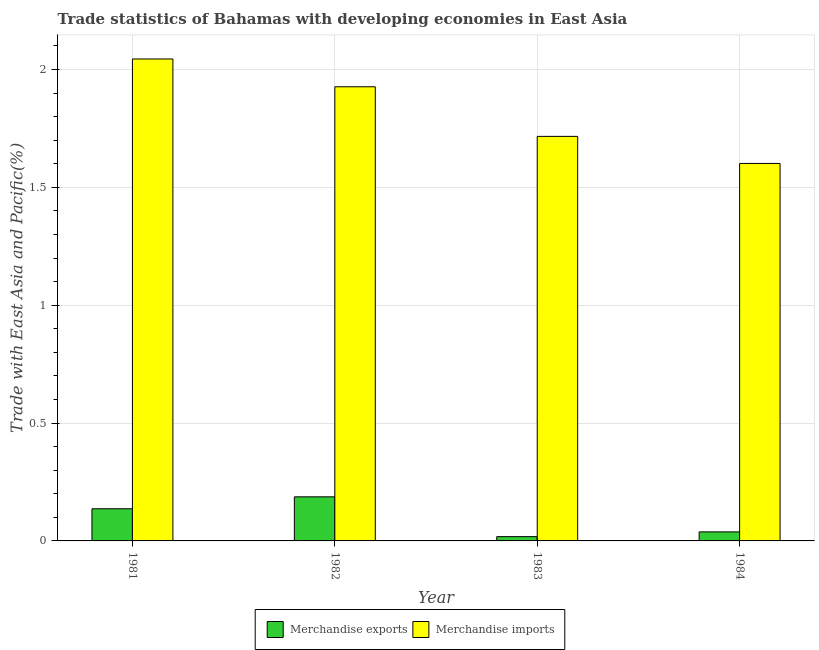How many different coloured bars are there?
Give a very brief answer. 2. How many groups of bars are there?
Offer a very short reply. 4. Are the number of bars on each tick of the X-axis equal?
Provide a succinct answer. Yes. How many bars are there on the 3rd tick from the right?
Ensure brevity in your answer.  2. What is the merchandise imports in 1983?
Offer a terse response. 1.72. Across all years, what is the maximum merchandise exports?
Make the answer very short. 0.19. Across all years, what is the minimum merchandise exports?
Make the answer very short. 0.02. In which year was the merchandise exports minimum?
Give a very brief answer. 1983. What is the total merchandise imports in the graph?
Your response must be concise. 7.29. What is the difference between the merchandise imports in 1981 and that in 1984?
Offer a very short reply. 0.44. What is the difference between the merchandise exports in 1981 and the merchandise imports in 1982?
Your answer should be compact. -0.05. What is the average merchandise exports per year?
Keep it short and to the point. 0.09. In the year 1981, what is the difference between the merchandise exports and merchandise imports?
Your response must be concise. 0. What is the ratio of the merchandise imports in 1981 to that in 1983?
Make the answer very short. 1.19. What is the difference between the highest and the second highest merchandise exports?
Your answer should be compact. 0.05. What is the difference between the highest and the lowest merchandise imports?
Make the answer very short. 0.44. What does the 2nd bar from the left in 1983 represents?
Make the answer very short. Merchandise imports. What does the 1st bar from the right in 1983 represents?
Your answer should be very brief. Merchandise imports. Are all the bars in the graph horizontal?
Offer a terse response. No. What is the difference between two consecutive major ticks on the Y-axis?
Provide a succinct answer. 0.5. Are the values on the major ticks of Y-axis written in scientific E-notation?
Keep it short and to the point. No. Does the graph contain any zero values?
Your answer should be very brief. No. Where does the legend appear in the graph?
Offer a very short reply. Bottom center. How many legend labels are there?
Give a very brief answer. 2. How are the legend labels stacked?
Ensure brevity in your answer.  Horizontal. What is the title of the graph?
Your response must be concise. Trade statistics of Bahamas with developing economies in East Asia. Does "IMF nonconcessional" appear as one of the legend labels in the graph?
Your answer should be compact. No. What is the label or title of the Y-axis?
Your answer should be very brief. Trade with East Asia and Pacific(%). What is the Trade with East Asia and Pacific(%) in Merchandise exports in 1981?
Your answer should be compact. 0.14. What is the Trade with East Asia and Pacific(%) in Merchandise imports in 1981?
Your answer should be compact. 2.04. What is the Trade with East Asia and Pacific(%) in Merchandise exports in 1982?
Your response must be concise. 0.19. What is the Trade with East Asia and Pacific(%) of Merchandise imports in 1982?
Provide a short and direct response. 1.93. What is the Trade with East Asia and Pacific(%) in Merchandise exports in 1983?
Provide a short and direct response. 0.02. What is the Trade with East Asia and Pacific(%) in Merchandise imports in 1983?
Ensure brevity in your answer.  1.72. What is the Trade with East Asia and Pacific(%) of Merchandise exports in 1984?
Keep it short and to the point. 0.04. What is the Trade with East Asia and Pacific(%) in Merchandise imports in 1984?
Your answer should be compact. 1.6. Across all years, what is the maximum Trade with East Asia and Pacific(%) in Merchandise exports?
Offer a terse response. 0.19. Across all years, what is the maximum Trade with East Asia and Pacific(%) of Merchandise imports?
Give a very brief answer. 2.04. Across all years, what is the minimum Trade with East Asia and Pacific(%) in Merchandise exports?
Your response must be concise. 0.02. Across all years, what is the minimum Trade with East Asia and Pacific(%) of Merchandise imports?
Your response must be concise. 1.6. What is the total Trade with East Asia and Pacific(%) in Merchandise exports in the graph?
Make the answer very short. 0.38. What is the total Trade with East Asia and Pacific(%) of Merchandise imports in the graph?
Your answer should be compact. 7.29. What is the difference between the Trade with East Asia and Pacific(%) in Merchandise exports in 1981 and that in 1982?
Offer a terse response. -0.05. What is the difference between the Trade with East Asia and Pacific(%) of Merchandise imports in 1981 and that in 1982?
Your answer should be compact. 0.12. What is the difference between the Trade with East Asia and Pacific(%) in Merchandise exports in 1981 and that in 1983?
Make the answer very short. 0.12. What is the difference between the Trade with East Asia and Pacific(%) in Merchandise imports in 1981 and that in 1983?
Offer a very short reply. 0.33. What is the difference between the Trade with East Asia and Pacific(%) of Merchandise exports in 1981 and that in 1984?
Your answer should be very brief. 0.1. What is the difference between the Trade with East Asia and Pacific(%) of Merchandise imports in 1981 and that in 1984?
Offer a very short reply. 0.44. What is the difference between the Trade with East Asia and Pacific(%) of Merchandise exports in 1982 and that in 1983?
Offer a terse response. 0.17. What is the difference between the Trade with East Asia and Pacific(%) in Merchandise imports in 1982 and that in 1983?
Give a very brief answer. 0.21. What is the difference between the Trade with East Asia and Pacific(%) of Merchandise exports in 1982 and that in 1984?
Your answer should be compact. 0.15. What is the difference between the Trade with East Asia and Pacific(%) of Merchandise imports in 1982 and that in 1984?
Give a very brief answer. 0.33. What is the difference between the Trade with East Asia and Pacific(%) in Merchandise exports in 1983 and that in 1984?
Give a very brief answer. -0.02. What is the difference between the Trade with East Asia and Pacific(%) of Merchandise imports in 1983 and that in 1984?
Ensure brevity in your answer.  0.11. What is the difference between the Trade with East Asia and Pacific(%) of Merchandise exports in 1981 and the Trade with East Asia and Pacific(%) of Merchandise imports in 1982?
Ensure brevity in your answer.  -1.79. What is the difference between the Trade with East Asia and Pacific(%) in Merchandise exports in 1981 and the Trade with East Asia and Pacific(%) in Merchandise imports in 1983?
Keep it short and to the point. -1.58. What is the difference between the Trade with East Asia and Pacific(%) of Merchandise exports in 1981 and the Trade with East Asia and Pacific(%) of Merchandise imports in 1984?
Offer a terse response. -1.47. What is the difference between the Trade with East Asia and Pacific(%) in Merchandise exports in 1982 and the Trade with East Asia and Pacific(%) in Merchandise imports in 1983?
Keep it short and to the point. -1.53. What is the difference between the Trade with East Asia and Pacific(%) in Merchandise exports in 1982 and the Trade with East Asia and Pacific(%) in Merchandise imports in 1984?
Give a very brief answer. -1.41. What is the difference between the Trade with East Asia and Pacific(%) of Merchandise exports in 1983 and the Trade with East Asia and Pacific(%) of Merchandise imports in 1984?
Ensure brevity in your answer.  -1.58. What is the average Trade with East Asia and Pacific(%) in Merchandise exports per year?
Offer a terse response. 0.09. What is the average Trade with East Asia and Pacific(%) in Merchandise imports per year?
Provide a short and direct response. 1.82. In the year 1981, what is the difference between the Trade with East Asia and Pacific(%) of Merchandise exports and Trade with East Asia and Pacific(%) of Merchandise imports?
Keep it short and to the point. -1.91. In the year 1982, what is the difference between the Trade with East Asia and Pacific(%) in Merchandise exports and Trade with East Asia and Pacific(%) in Merchandise imports?
Provide a succinct answer. -1.74. In the year 1983, what is the difference between the Trade with East Asia and Pacific(%) in Merchandise exports and Trade with East Asia and Pacific(%) in Merchandise imports?
Offer a terse response. -1.7. In the year 1984, what is the difference between the Trade with East Asia and Pacific(%) of Merchandise exports and Trade with East Asia and Pacific(%) of Merchandise imports?
Your response must be concise. -1.56. What is the ratio of the Trade with East Asia and Pacific(%) in Merchandise exports in 1981 to that in 1982?
Your answer should be compact. 0.73. What is the ratio of the Trade with East Asia and Pacific(%) in Merchandise imports in 1981 to that in 1982?
Your response must be concise. 1.06. What is the ratio of the Trade with East Asia and Pacific(%) in Merchandise exports in 1981 to that in 1983?
Provide a succinct answer. 7.52. What is the ratio of the Trade with East Asia and Pacific(%) of Merchandise imports in 1981 to that in 1983?
Provide a short and direct response. 1.19. What is the ratio of the Trade with East Asia and Pacific(%) of Merchandise exports in 1981 to that in 1984?
Ensure brevity in your answer.  3.56. What is the ratio of the Trade with East Asia and Pacific(%) in Merchandise imports in 1981 to that in 1984?
Ensure brevity in your answer.  1.28. What is the ratio of the Trade with East Asia and Pacific(%) of Merchandise exports in 1982 to that in 1983?
Your answer should be compact. 10.31. What is the ratio of the Trade with East Asia and Pacific(%) in Merchandise imports in 1982 to that in 1983?
Keep it short and to the point. 1.12. What is the ratio of the Trade with East Asia and Pacific(%) of Merchandise exports in 1982 to that in 1984?
Your response must be concise. 4.89. What is the ratio of the Trade with East Asia and Pacific(%) of Merchandise imports in 1982 to that in 1984?
Your answer should be very brief. 1.2. What is the ratio of the Trade with East Asia and Pacific(%) in Merchandise exports in 1983 to that in 1984?
Your answer should be compact. 0.47. What is the ratio of the Trade with East Asia and Pacific(%) of Merchandise imports in 1983 to that in 1984?
Offer a very short reply. 1.07. What is the difference between the highest and the second highest Trade with East Asia and Pacific(%) of Merchandise exports?
Your answer should be compact. 0.05. What is the difference between the highest and the second highest Trade with East Asia and Pacific(%) of Merchandise imports?
Keep it short and to the point. 0.12. What is the difference between the highest and the lowest Trade with East Asia and Pacific(%) in Merchandise exports?
Offer a very short reply. 0.17. What is the difference between the highest and the lowest Trade with East Asia and Pacific(%) of Merchandise imports?
Your answer should be very brief. 0.44. 